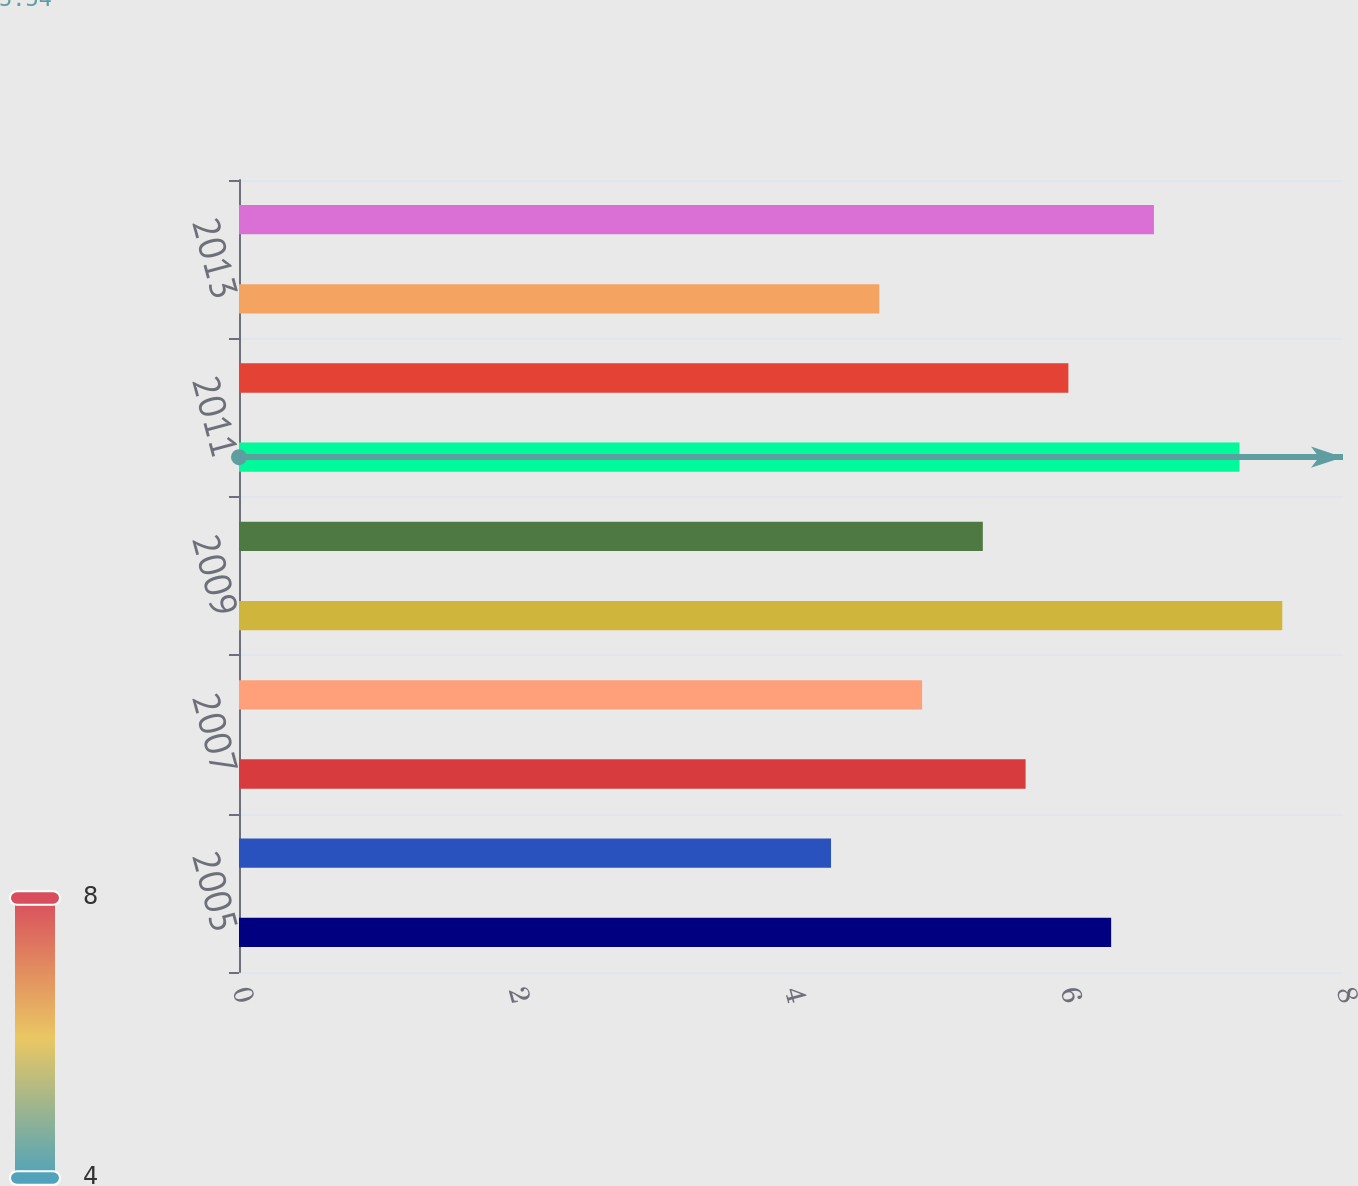Convert chart. <chart><loc_0><loc_0><loc_500><loc_500><bar_chart><fcel>2005<fcel>2006<fcel>2007<fcel>2008<fcel>2009<fcel>2010<fcel>2011<fcel>2012<fcel>2013<fcel>2014<nl><fcel>6.32<fcel>4.29<fcel>5.7<fcel>4.95<fcel>7.56<fcel>5.39<fcel>7.25<fcel>6.01<fcel>4.64<fcel>6.63<nl></chart> 